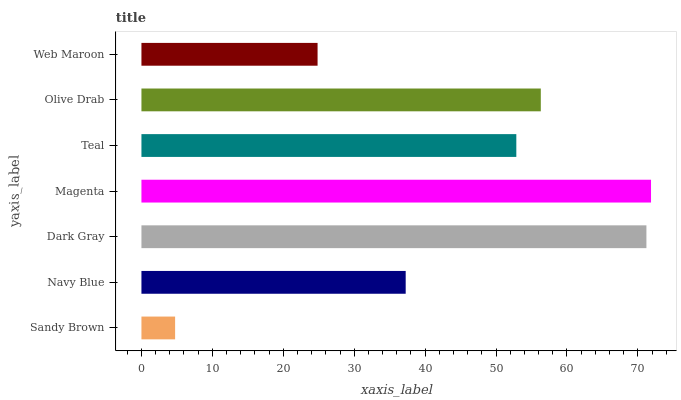Is Sandy Brown the minimum?
Answer yes or no. Yes. Is Magenta the maximum?
Answer yes or no. Yes. Is Navy Blue the minimum?
Answer yes or no. No. Is Navy Blue the maximum?
Answer yes or no. No. Is Navy Blue greater than Sandy Brown?
Answer yes or no. Yes. Is Sandy Brown less than Navy Blue?
Answer yes or no. Yes. Is Sandy Brown greater than Navy Blue?
Answer yes or no. No. Is Navy Blue less than Sandy Brown?
Answer yes or no. No. Is Teal the high median?
Answer yes or no. Yes. Is Teal the low median?
Answer yes or no. Yes. Is Web Maroon the high median?
Answer yes or no. No. Is Dark Gray the low median?
Answer yes or no. No. 